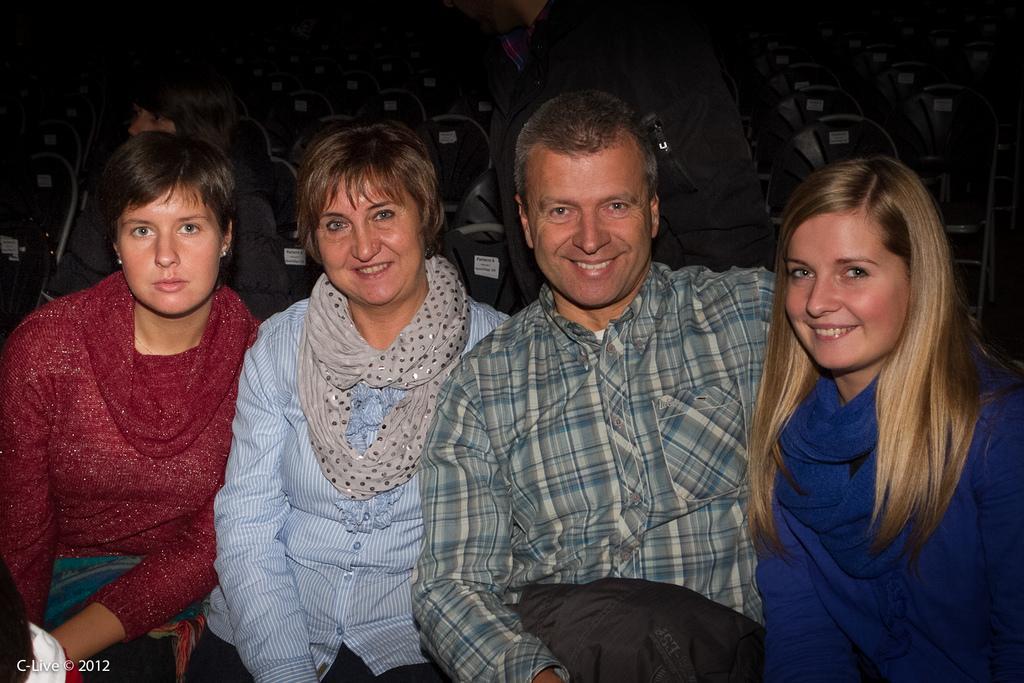In one or two sentences, can you explain what this image depicts? There are four persons in different color dresses sitting on chairs and smiling. In the background, there is a person standing, there is a person sitting on other chair, there are chairs arranged. And the background is dark in color. 